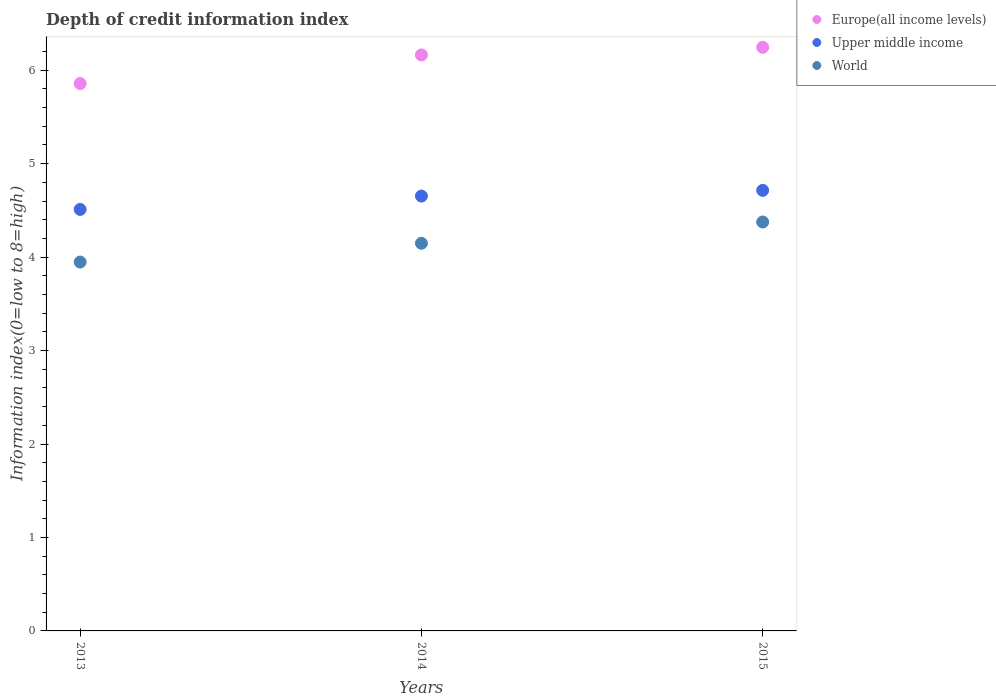What is the information index in Upper middle income in 2014?
Offer a terse response. 4.65. Across all years, what is the maximum information index in Europe(all income levels)?
Your response must be concise. 6.24. Across all years, what is the minimum information index in Europe(all income levels)?
Provide a short and direct response. 5.86. In which year was the information index in Europe(all income levels) maximum?
Ensure brevity in your answer.  2015. What is the total information index in World in the graph?
Ensure brevity in your answer.  12.47. What is the difference between the information index in Europe(all income levels) in 2013 and that in 2015?
Give a very brief answer. -0.39. What is the difference between the information index in World in 2013 and the information index in Upper middle income in 2014?
Offer a terse response. -0.71. What is the average information index in Europe(all income levels) per year?
Ensure brevity in your answer.  6.09. In the year 2014, what is the difference between the information index in Upper middle income and information index in Europe(all income levels)?
Provide a short and direct response. -1.51. In how many years, is the information index in Europe(all income levels) greater than 5.8?
Keep it short and to the point. 3. What is the ratio of the information index in Europe(all income levels) in 2013 to that in 2015?
Offer a terse response. 0.94. What is the difference between the highest and the second highest information index in Europe(all income levels)?
Provide a short and direct response. 0.08. What is the difference between the highest and the lowest information index in Upper middle income?
Provide a succinct answer. 0.2. Does the information index in Upper middle income monotonically increase over the years?
Your response must be concise. Yes. Is the information index in Europe(all income levels) strictly less than the information index in Upper middle income over the years?
Provide a succinct answer. No. How many dotlines are there?
Your answer should be compact. 3. Does the graph contain any zero values?
Your response must be concise. No. How are the legend labels stacked?
Keep it short and to the point. Vertical. What is the title of the graph?
Make the answer very short. Depth of credit information index. What is the label or title of the X-axis?
Offer a very short reply. Years. What is the label or title of the Y-axis?
Give a very brief answer. Information index(0=low to 8=high). What is the Information index(0=low to 8=high) of Europe(all income levels) in 2013?
Your response must be concise. 5.86. What is the Information index(0=low to 8=high) in Upper middle income in 2013?
Your answer should be compact. 4.51. What is the Information index(0=low to 8=high) in World in 2013?
Offer a very short reply. 3.95. What is the Information index(0=low to 8=high) in Europe(all income levels) in 2014?
Offer a very short reply. 6.16. What is the Information index(0=low to 8=high) in Upper middle income in 2014?
Offer a very short reply. 4.65. What is the Information index(0=low to 8=high) in World in 2014?
Make the answer very short. 4.15. What is the Information index(0=low to 8=high) in Europe(all income levels) in 2015?
Offer a very short reply. 6.24. What is the Information index(0=low to 8=high) of Upper middle income in 2015?
Give a very brief answer. 4.71. What is the Information index(0=low to 8=high) of World in 2015?
Your answer should be compact. 4.38. Across all years, what is the maximum Information index(0=low to 8=high) in Europe(all income levels)?
Your response must be concise. 6.24. Across all years, what is the maximum Information index(0=low to 8=high) of Upper middle income?
Ensure brevity in your answer.  4.71. Across all years, what is the maximum Information index(0=low to 8=high) in World?
Offer a terse response. 4.38. Across all years, what is the minimum Information index(0=low to 8=high) in Europe(all income levels)?
Give a very brief answer. 5.86. Across all years, what is the minimum Information index(0=low to 8=high) in Upper middle income?
Your answer should be very brief. 4.51. Across all years, what is the minimum Information index(0=low to 8=high) in World?
Your answer should be very brief. 3.95. What is the total Information index(0=low to 8=high) of Europe(all income levels) in the graph?
Offer a terse response. 18.27. What is the total Information index(0=low to 8=high) in Upper middle income in the graph?
Your answer should be compact. 13.88. What is the total Information index(0=low to 8=high) of World in the graph?
Offer a very short reply. 12.47. What is the difference between the Information index(0=low to 8=high) of Europe(all income levels) in 2013 and that in 2014?
Provide a short and direct response. -0.31. What is the difference between the Information index(0=low to 8=high) in Upper middle income in 2013 and that in 2014?
Your answer should be compact. -0.14. What is the difference between the Information index(0=low to 8=high) in World in 2013 and that in 2014?
Provide a short and direct response. -0.2. What is the difference between the Information index(0=low to 8=high) of Europe(all income levels) in 2013 and that in 2015?
Offer a very short reply. -0.39. What is the difference between the Information index(0=low to 8=high) of Upper middle income in 2013 and that in 2015?
Give a very brief answer. -0.2. What is the difference between the Information index(0=low to 8=high) of World in 2013 and that in 2015?
Your answer should be compact. -0.43. What is the difference between the Information index(0=low to 8=high) of Europe(all income levels) in 2014 and that in 2015?
Ensure brevity in your answer.  -0.08. What is the difference between the Information index(0=low to 8=high) in Upper middle income in 2014 and that in 2015?
Your response must be concise. -0.06. What is the difference between the Information index(0=low to 8=high) in World in 2014 and that in 2015?
Provide a succinct answer. -0.23. What is the difference between the Information index(0=low to 8=high) of Europe(all income levels) in 2013 and the Information index(0=low to 8=high) of Upper middle income in 2014?
Offer a terse response. 1.2. What is the difference between the Information index(0=low to 8=high) in Europe(all income levels) in 2013 and the Information index(0=low to 8=high) in World in 2014?
Your response must be concise. 1.71. What is the difference between the Information index(0=low to 8=high) in Upper middle income in 2013 and the Information index(0=low to 8=high) in World in 2014?
Your response must be concise. 0.36. What is the difference between the Information index(0=low to 8=high) in Europe(all income levels) in 2013 and the Information index(0=low to 8=high) in Upper middle income in 2015?
Provide a short and direct response. 1.14. What is the difference between the Information index(0=low to 8=high) of Europe(all income levels) in 2013 and the Information index(0=low to 8=high) of World in 2015?
Keep it short and to the point. 1.48. What is the difference between the Information index(0=low to 8=high) of Upper middle income in 2013 and the Information index(0=low to 8=high) of World in 2015?
Give a very brief answer. 0.13. What is the difference between the Information index(0=low to 8=high) of Europe(all income levels) in 2014 and the Information index(0=low to 8=high) of Upper middle income in 2015?
Give a very brief answer. 1.45. What is the difference between the Information index(0=low to 8=high) in Europe(all income levels) in 2014 and the Information index(0=low to 8=high) in World in 2015?
Make the answer very short. 1.79. What is the difference between the Information index(0=low to 8=high) in Upper middle income in 2014 and the Information index(0=low to 8=high) in World in 2015?
Offer a very short reply. 0.28. What is the average Information index(0=low to 8=high) of Europe(all income levels) per year?
Offer a terse response. 6.09. What is the average Information index(0=low to 8=high) in Upper middle income per year?
Your answer should be very brief. 4.63. What is the average Information index(0=low to 8=high) of World per year?
Offer a very short reply. 4.16. In the year 2013, what is the difference between the Information index(0=low to 8=high) of Europe(all income levels) and Information index(0=low to 8=high) of Upper middle income?
Keep it short and to the point. 1.35. In the year 2013, what is the difference between the Information index(0=low to 8=high) in Europe(all income levels) and Information index(0=low to 8=high) in World?
Offer a terse response. 1.91. In the year 2013, what is the difference between the Information index(0=low to 8=high) of Upper middle income and Information index(0=low to 8=high) of World?
Ensure brevity in your answer.  0.56. In the year 2014, what is the difference between the Information index(0=low to 8=high) of Europe(all income levels) and Information index(0=low to 8=high) of Upper middle income?
Ensure brevity in your answer.  1.51. In the year 2014, what is the difference between the Information index(0=low to 8=high) of Europe(all income levels) and Information index(0=low to 8=high) of World?
Offer a very short reply. 2.02. In the year 2014, what is the difference between the Information index(0=low to 8=high) of Upper middle income and Information index(0=low to 8=high) of World?
Offer a terse response. 0.5. In the year 2015, what is the difference between the Information index(0=low to 8=high) in Europe(all income levels) and Information index(0=low to 8=high) in Upper middle income?
Your response must be concise. 1.53. In the year 2015, what is the difference between the Information index(0=low to 8=high) of Europe(all income levels) and Information index(0=low to 8=high) of World?
Provide a short and direct response. 1.87. In the year 2015, what is the difference between the Information index(0=low to 8=high) of Upper middle income and Information index(0=low to 8=high) of World?
Ensure brevity in your answer.  0.34. What is the ratio of the Information index(0=low to 8=high) in Europe(all income levels) in 2013 to that in 2014?
Give a very brief answer. 0.95. What is the ratio of the Information index(0=low to 8=high) of Upper middle income in 2013 to that in 2014?
Provide a short and direct response. 0.97. What is the ratio of the Information index(0=low to 8=high) of World in 2013 to that in 2014?
Offer a terse response. 0.95. What is the ratio of the Information index(0=low to 8=high) of Europe(all income levels) in 2013 to that in 2015?
Give a very brief answer. 0.94. What is the ratio of the Information index(0=low to 8=high) of Upper middle income in 2013 to that in 2015?
Ensure brevity in your answer.  0.96. What is the ratio of the Information index(0=low to 8=high) of World in 2013 to that in 2015?
Give a very brief answer. 0.9. What is the ratio of the Information index(0=low to 8=high) of Europe(all income levels) in 2014 to that in 2015?
Ensure brevity in your answer.  0.99. What is the ratio of the Information index(0=low to 8=high) of Upper middle income in 2014 to that in 2015?
Give a very brief answer. 0.99. What is the ratio of the Information index(0=low to 8=high) in World in 2014 to that in 2015?
Provide a short and direct response. 0.95. What is the difference between the highest and the second highest Information index(0=low to 8=high) in Europe(all income levels)?
Provide a succinct answer. 0.08. What is the difference between the highest and the second highest Information index(0=low to 8=high) of Upper middle income?
Keep it short and to the point. 0.06. What is the difference between the highest and the second highest Information index(0=low to 8=high) in World?
Offer a terse response. 0.23. What is the difference between the highest and the lowest Information index(0=low to 8=high) of Europe(all income levels)?
Offer a very short reply. 0.39. What is the difference between the highest and the lowest Information index(0=low to 8=high) in Upper middle income?
Keep it short and to the point. 0.2. What is the difference between the highest and the lowest Information index(0=low to 8=high) of World?
Offer a very short reply. 0.43. 